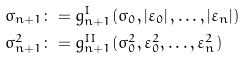Convert formula to latex. <formula><loc_0><loc_0><loc_500><loc_500>\sigma _ { n + 1 } & \colon = g _ { n + 1 } ^ { I } ( \sigma _ { 0 } , \left | \varepsilon _ { 0 } \right | , \dots , \left | \varepsilon _ { n } \right | ) \\ \sigma _ { n + 1 } ^ { 2 } & \colon = g _ { n + 1 } ^ { I I } ( \sigma _ { 0 } ^ { 2 } , \varepsilon _ { 0 } ^ { 2 } , \dots , \varepsilon _ { n } ^ { 2 } )</formula> 